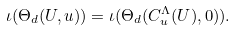<formula> <loc_0><loc_0><loc_500><loc_500>\iota ( \Theta _ { d } ( U , u ) ) = \iota ( \Theta _ { d } ( C _ { u } ^ { \Lambda } ( U ) , 0 ) ) .</formula> 